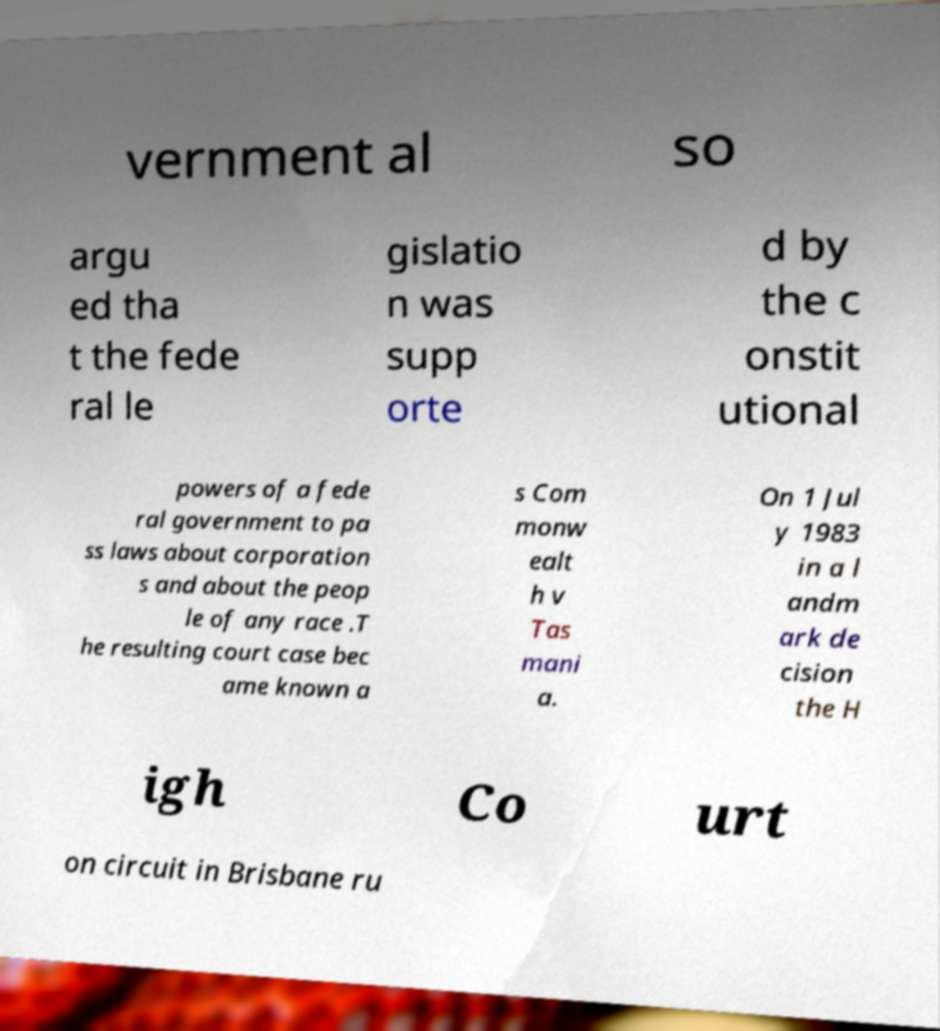Please identify and transcribe the text found in this image. vernment al so argu ed tha t the fede ral le gislatio n was supp orte d by the c onstit utional powers of a fede ral government to pa ss laws about corporation s and about the peop le of any race .T he resulting court case bec ame known a s Com monw ealt h v Tas mani a. On 1 Jul y 1983 in a l andm ark de cision the H igh Co urt on circuit in Brisbane ru 